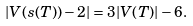<formula> <loc_0><loc_0><loc_500><loc_500>| V ( s ( T ) ) - 2 | = 3 | V ( T ) | - 6 .</formula> 